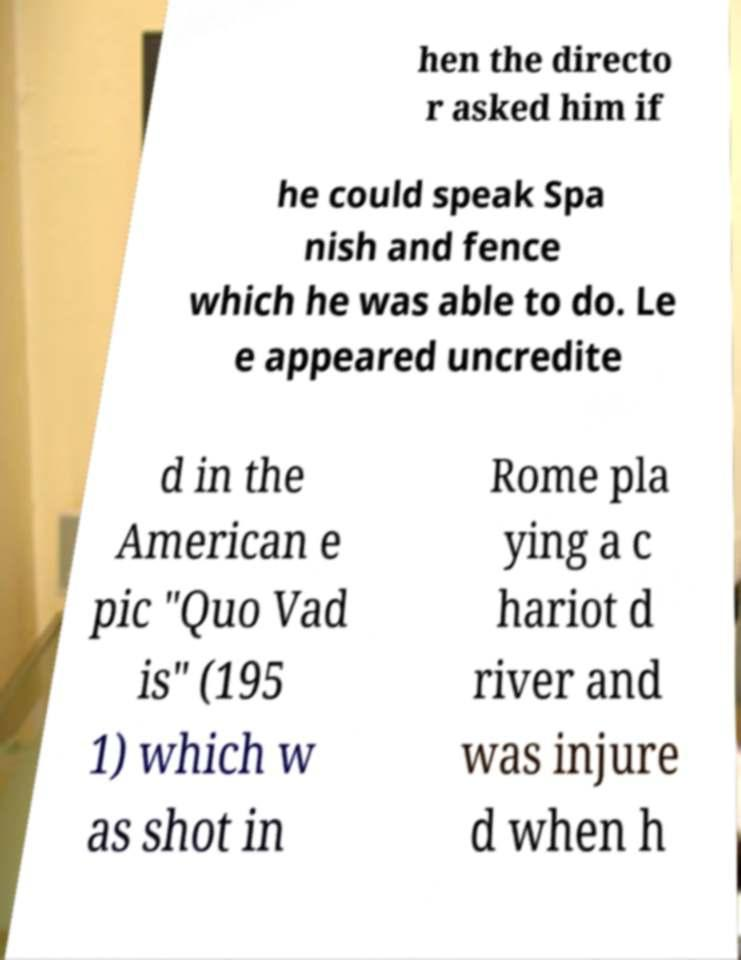For documentation purposes, I need the text within this image transcribed. Could you provide that? hen the directo r asked him if he could speak Spa nish and fence which he was able to do. Le e appeared uncredite d in the American e pic "Quo Vad is" (195 1) which w as shot in Rome pla ying a c hariot d river and was injure d when h 